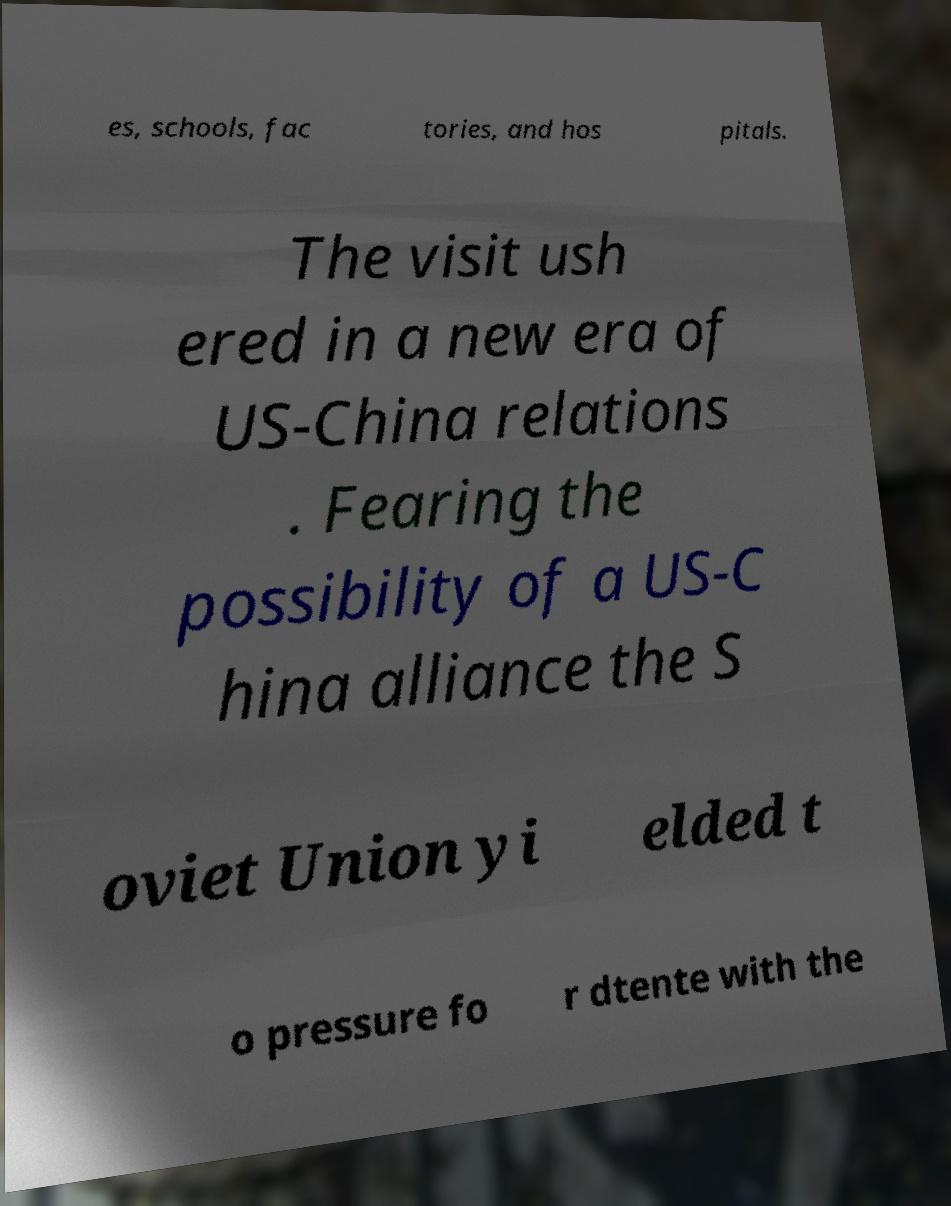For documentation purposes, I need the text within this image transcribed. Could you provide that? es, schools, fac tories, and hos pitals. The visit ush ered in a new era of US-China relations . Fearing the possibility of a US-C hina alliance the S oviet Union yi elded t o pressure fo r dtente with the 